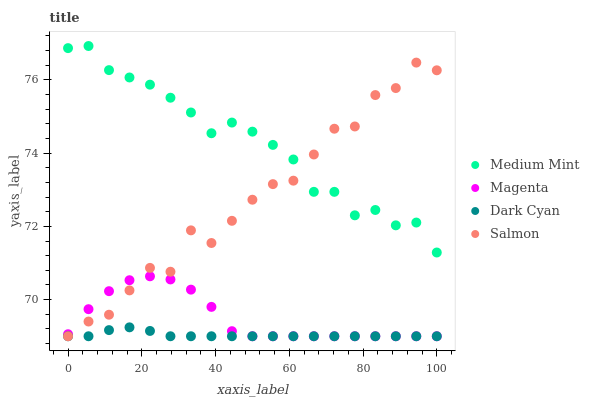Does Dark Cyan have the minimum area under the curve?
Answer yes or no. Yes. Does Medium Mint have the maximum area under the curve?
Answer yes or no. Yes. Does Magenta have the minimum area under the curve?
Answer yes or no. No. Does Magenta have the maximum area under the curve?
Answer yes or no. No. Is Dark Cyan the smoothest?
Answer yes or no. Yes. Is Salmon the roughest?
Answer yes or no. Yes. Is Magenta the smoothest?
Answer yes or no. No. Is Magenta the roughest?
Answer yes or no. No. Does Dark Cyan have the lowest value?
Answer yes or no. Yes. Does Medium Mint have the highest value?
Answer yes or no. Yes. Does Magenta have the highest value?
Answer yes or no. No. Is Dark Cyan less than Medium Mint?
Answer yes or no. Yes. Is Medium Mint greater than Dark Cyan?
Answer yes or no. Yes. Does Salmon intersect Dark Cyan?
Answer yes or no. Yes. Is Salmon less than Dark Cyan?
Answer yes or no. No. Is Salmon greater than Dark Cyan?
Answer yes or no. No. Does Dark Cyan intersect Medium Mint?
Answer yes or no. No. 